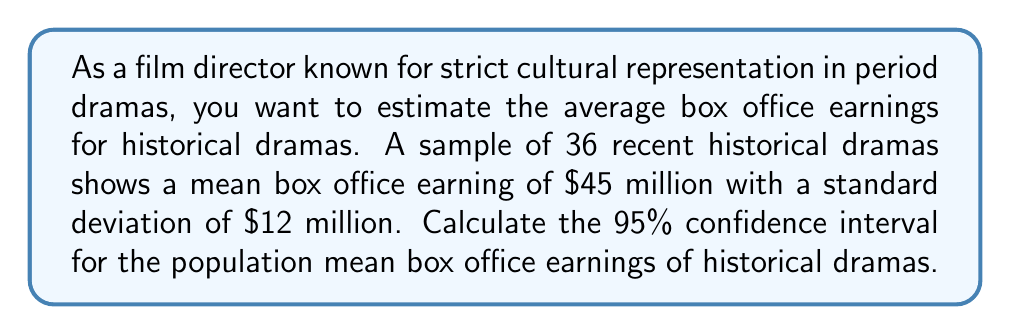What is the answer to this math problem? To calculate the confidence interval, we'll follow these steps:

1. Identify the given information:
   - Sample size: $n = 36$
   - Sample mean: $\bar{x} = \$45$ million
   - Sample standard deviation: $s = \$12$ million
   - Confidence level: 95% (α = 0.05)

2. Determine the critical value:
   For a 95% confidence level with df = 35, the t-critical value is approximately 2.030.

3. Calculate the standard error of the mean:
   $SE_{\bar{x}} = \frac{s}{\sqrt{n}} = \frac{12}{\sqrt{36}} = \frac{12}{6} = 2$

4. Calculate the margin of error:
   $E = t_{\alpha/2} \cdot SE_{\bar{x}} = 2.030 \cdot 2 = 4.06$

5. Compute the confidence interval:
   Lower bound: $\bar{x} - E = 45 - 4.06 = 40.94$
   Upper bound: $\bar{x} + E = 45 + 4.06 = 49.06$

Therefore, the 95% confidence interval for the population mean box office earnings of historical dramas is (\$40.94 million, \$49.06 million).
Answer: (\$40.94 million, \$49.06 million) 